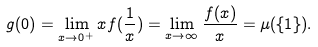Convert formula to latex. <formula><loc_0><loc_0><loc_500><loc_500>g ( 0 ) = \lim _ { x \to 0 ^ { + } } x f ( \frac { 1 } { x } ) = \lim _ { x \to \infty } \frac { f ( x ) } { x } = \mu ( \{ 1 \} ) .</formula> 